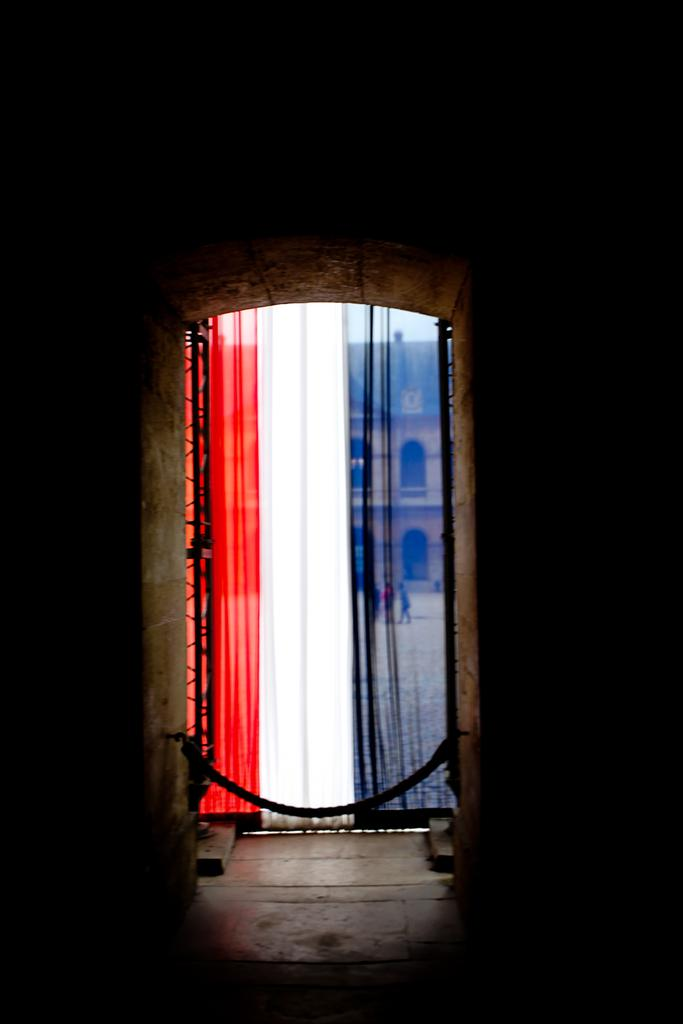What type of curtain is in the image? There is a colorful curtain in the image. What can be seen through the curtain? A building and people are visible through the curtain. How would you describe the lighting in the environment around the curtain? The environment around the curtain is dark. What condition is the vessel in, as seen through the curtain? There is no vessel present in the image, so it's not possible to determine its condition. 